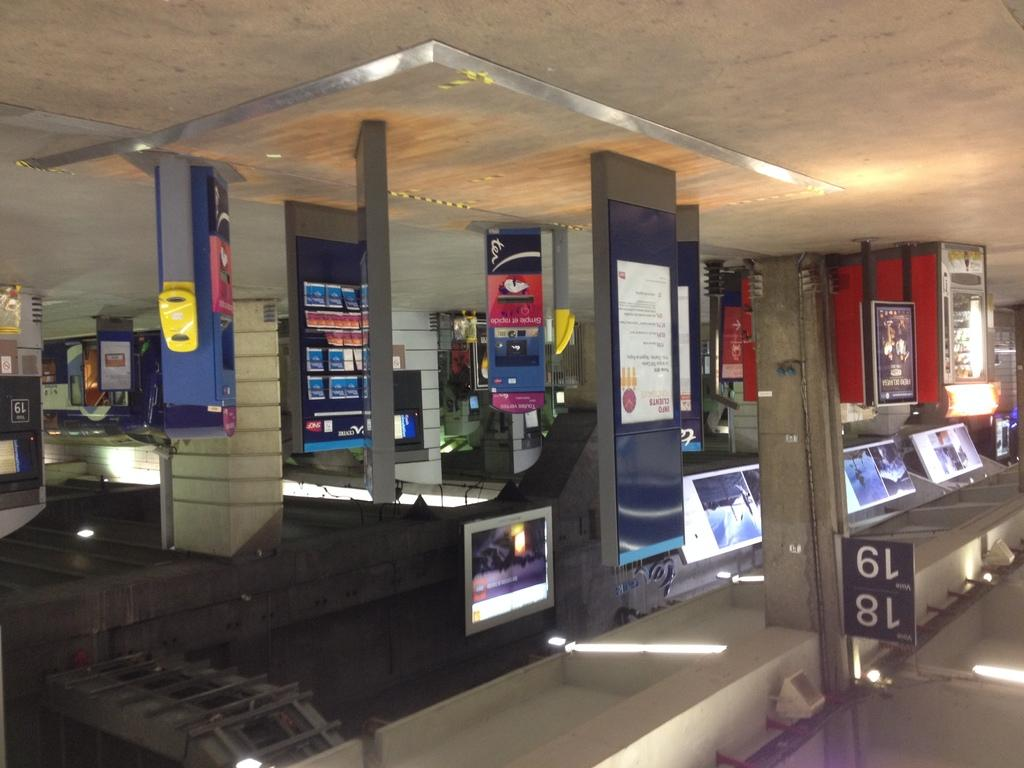<image>
Summarize the visual content of the image. the numbers 18 and 19 next to some area 